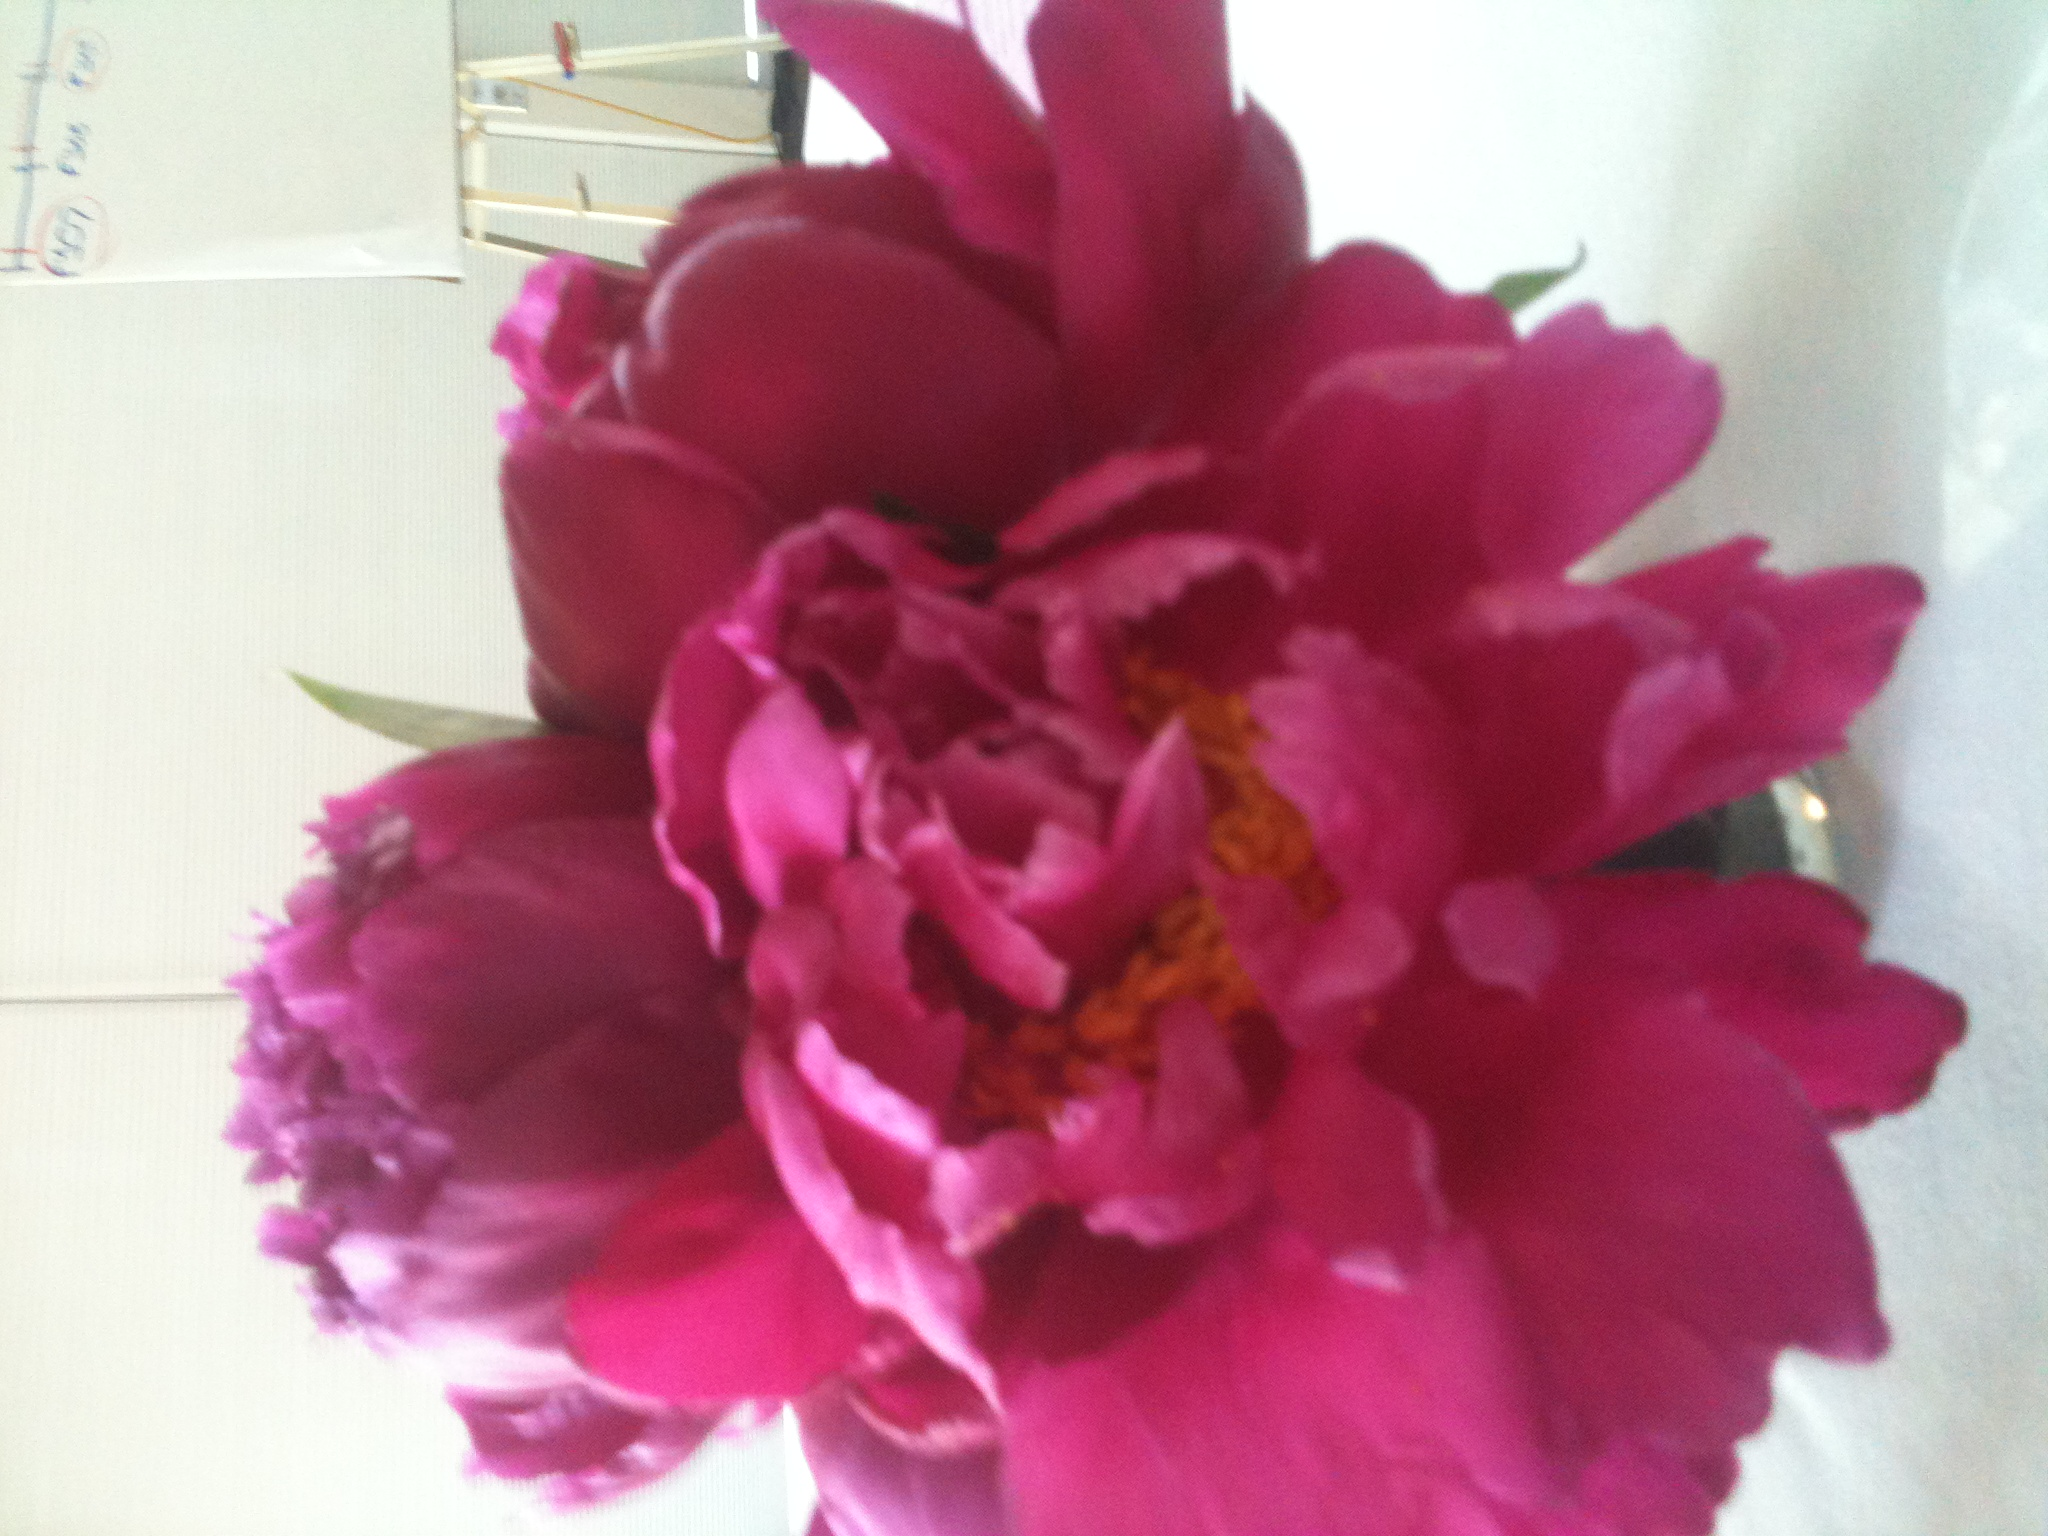If this flower could talk, what kind of stories would it tell? If this flower could talk, it would share tales of the countless moments it witnessed in people's lives. It might recall the joy of weddings where its petals adorned the aisles, the tender moments of loved ones exchanging flowers as tokens of affection, and the somber yet beautiful tributes at memorials. It would speak of the bees and butterflies that visited it daily, and the gentle hands of gardeners who nurtured it. Each bloom would carry a piece of history, a story of growth, care, and the transient beauty of life. In a short sentence, what can this flower symbolize? This flower symbolizes the fleeting but profound beauty of life's precious moments. Create a poetic description of this flower. In the morning's embrace, the peony unfurls, a vibrant dancer cloaked in pink, each petal whispering secrets of dawn. Its fragrance, a delicate symphony, weaves through the air, enchanting hearts and lifting spirits. Beneath the sun's gentle gaze, its lush blossoms shine, a fleeting masterpiece in nature’s grand gallery, telling tales of love, hope, and the poignant beauty of transience. Imagine a sci-fi scenario involving this flower. What role would it play? In a distant future on a terraformed Mars, scientists discovered that the peony flowers had adapted to the Martian soil in unique ways. They began to emit bioluminescent light and produced oxygen through a novel form of photosynthesis. These flowers were not only sources of beauty but also vital to the new colonies' air purification systems. One particular strain of pink peony was found to enhance cognitive functions when its aroma was inhaled, leading to breakthroughs in human potential. As a result, these flowers became both the heart of Martian gardens and pivotal components of advanced terraforming technologies. 